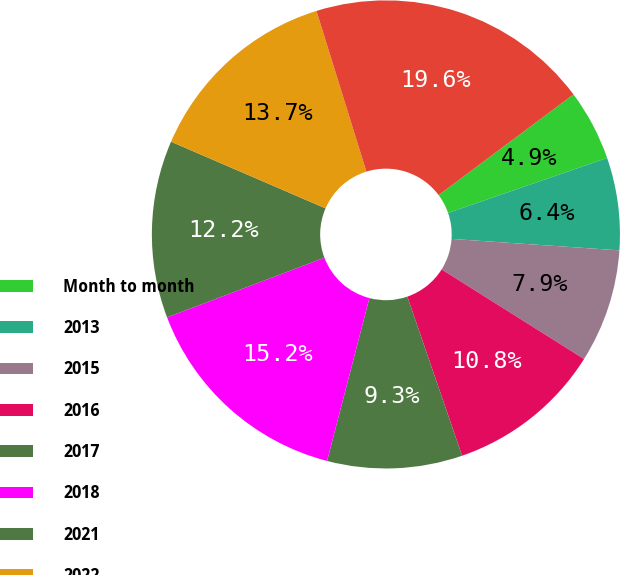<chart> <loc_0><loc_0><loc_500><loc_500><pie_chart><fcel>Month to month<fcel>2013<fcel>2015<fcel>2016<fcel>2017<fcel>2018<fcel>2021<fcel>2022<fcel>2014<nl><fcel>4.91%<fcel>6.38%<fcel>7.85%<fcel>10.79%<fcel>9.32%<fcel>15.19%<fcel>12.25%<fcel>13.72%<fcel>19.59%<nl></chart> 